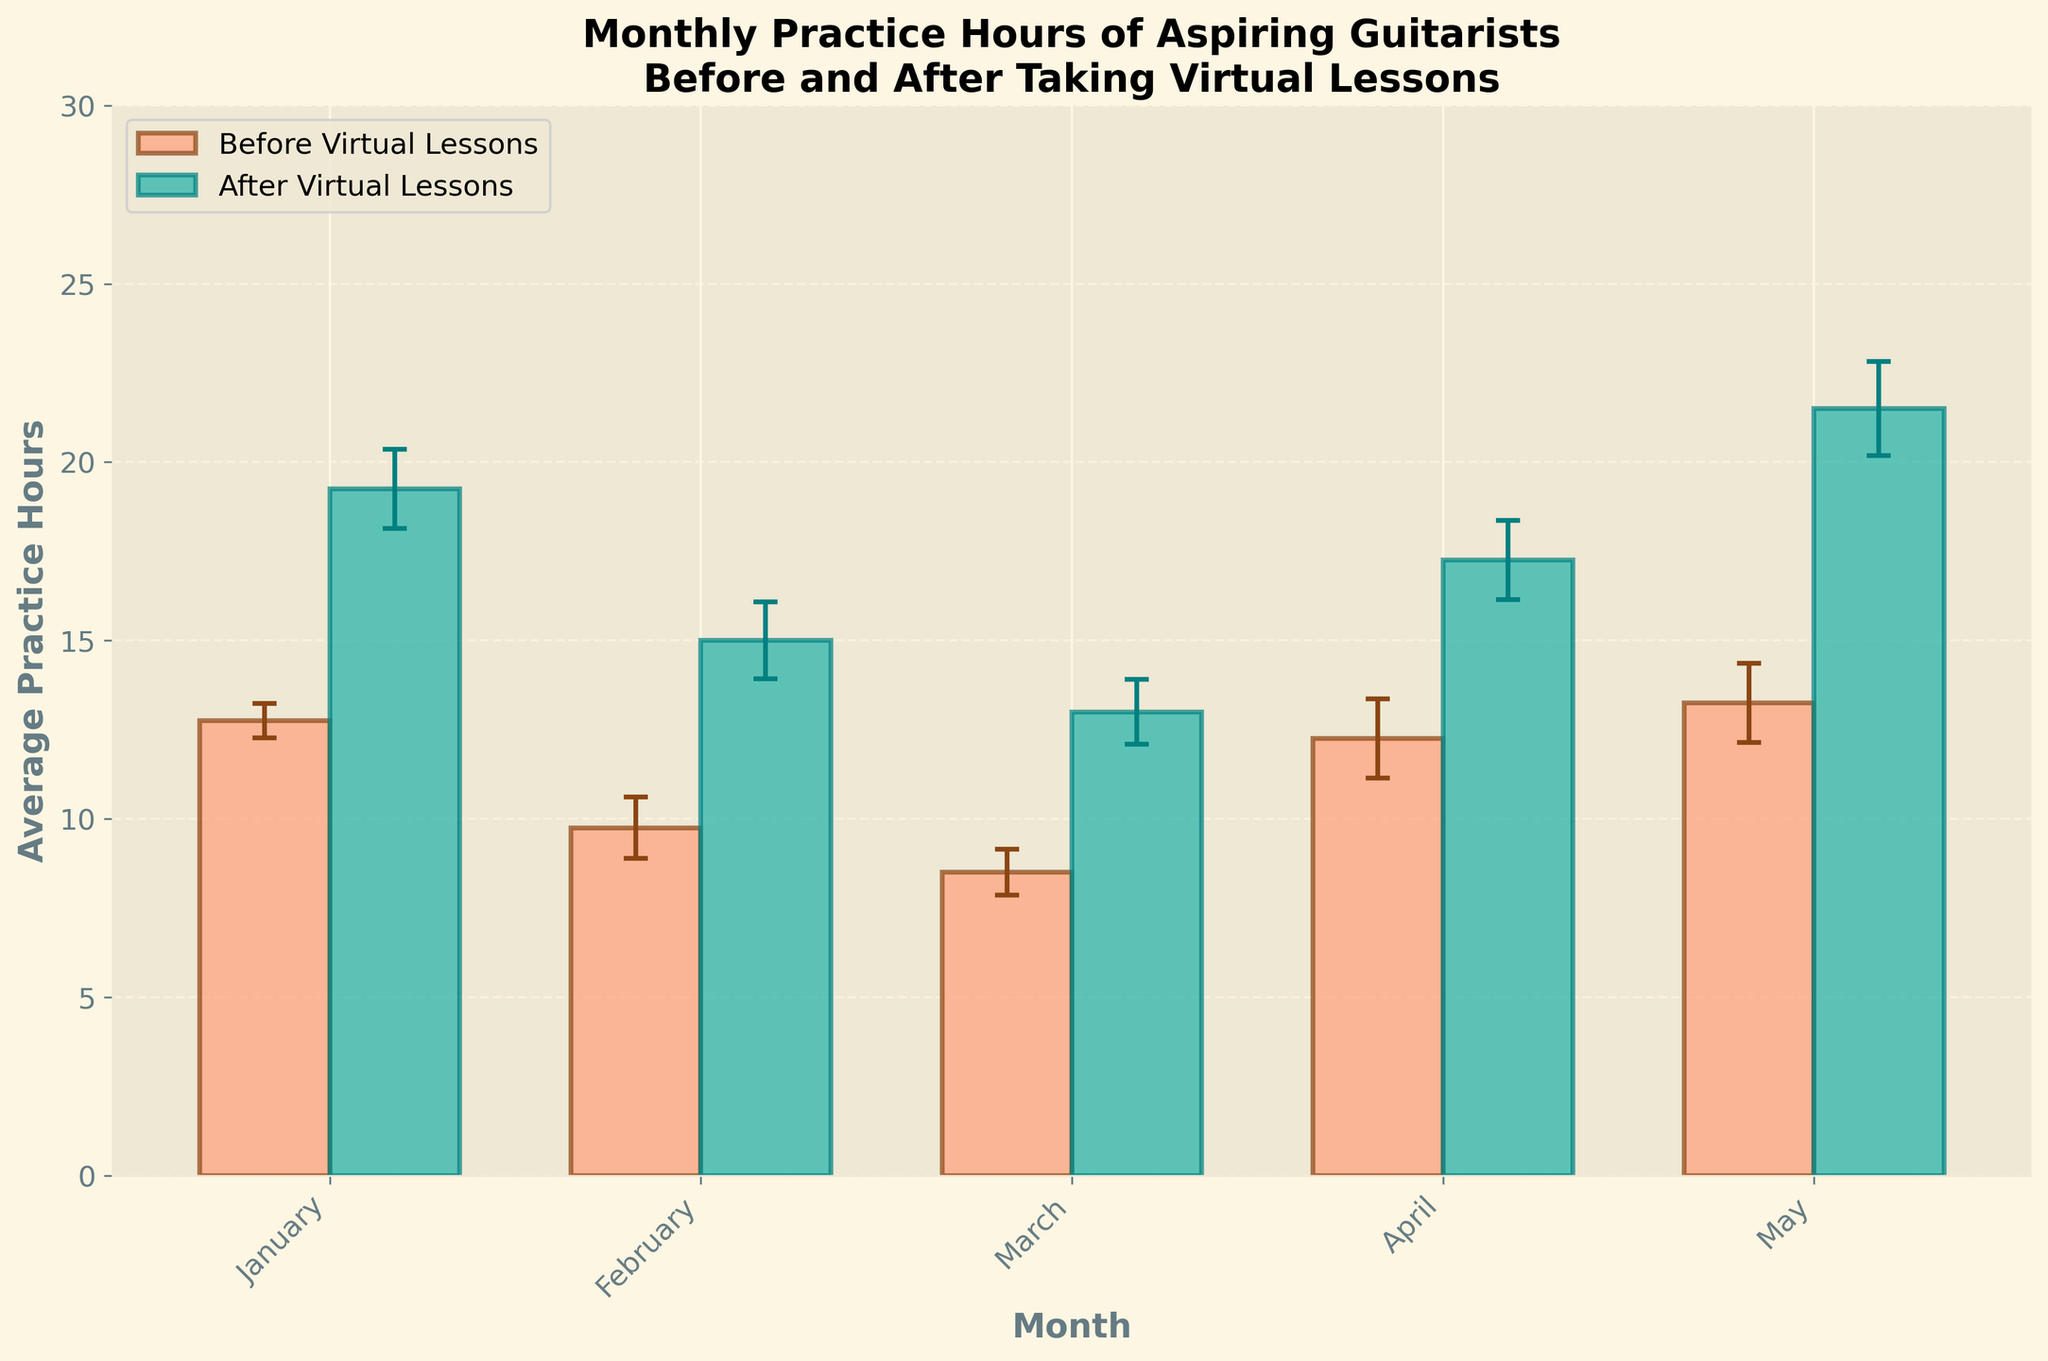What's the title of the plot? The title is usually displayed at the top of the plot. By referring to the figure, we see the title mentions "Monthly Practice Hours of Aspiring Guitarists" and "Before and After Taking Virtual Lessons".
Answer: Monthly Practice Hours of Aspiring Guitarists Before and After Taking Virtual Lessons Which color represents the practice hours before taking virtual lessons? Colors help distinguish different datasets. By referring to the legend in the figure, we see that the bars for practice hours before lessons are colored light orange.
Answer: Light Orange What month had the highest increase in average practice hours after taking virtual lessons? To find this, we need to compare the "Before" and "After" bars for each month and find the one with the largest difference. May has the largest increase when comparing the lengths of the bars.
Answer: May How many months are displayed in the plot? Count the number of tick labels on the x-axis, which represent the months. There are five months shown: January, February, March, April, and May.
Answer: 5 What is the average practice hours for April after taking virtual lessons? Look at the height of the green bar for April. According to the plot, it is approximately 20 hours.
Answer: 20 hours Is there any month where the average practice hours before were less than 10? Observe all the orange bars representing "Before" practice hours and check if any are below the 10-hour mark. January for Carlos is an example where practice hours before lessons were less than 10.
Answer: January Which guitarist had the highest increase in practice hours in any single month? Compare the increase in practice hours before and after lessons for each guitarist for each month. John Smith shows the highest increase from 16 to 25 hours in May.
Answer: John Smith in May Are the error bars for practice hours after lessons generally larger or smaller than those before lessons? Error bars reflect variability in the data. Compare the lengths of error bars for "After" and "Before" datasets. The error bars for "After" lessons are generally smaller.
Answer: Smaller By how many hours did Lucy Wang's average practice time increase from January to May after taking virtual lessons? Subtract the average practice hours in January from those in May for Lucy. The increase is from 14 to 22 hours. 22 - 14 = 8 hours.
Answer: 8 hours 